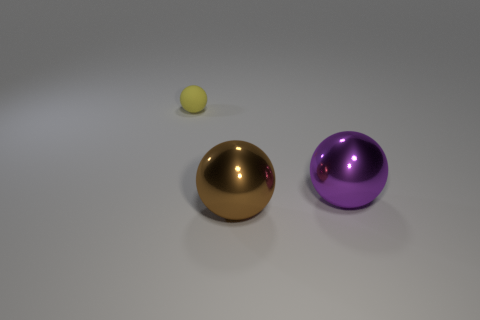Subtract all brown spheres. Subtract all yellow cylinders. How many spheres are left? 2 Add 2 rubber balls. How many objects exist? 5 Add 3 big purple metallic spheres. How many big purple metallic spheres are left? 4 Add 2 brown metal balls. How many brown metal balls exist? 3 Subtract 0 gray cylinders. How many objects are left? 3 Subtract all large purple shiny objects. Subtract all small things. How many objects are left? 1 